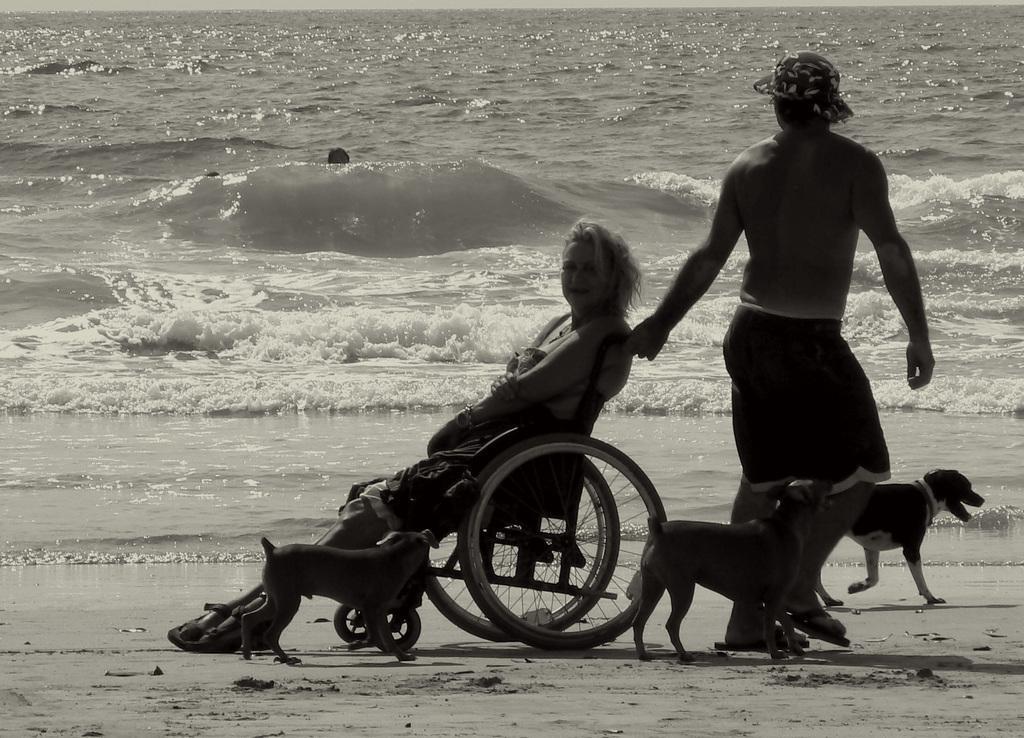Please provide a concise description of this image. This is a black and white picture, in this image we can see a person pulling a wheelchair, we can see a woman on the wheelchair, there are some dogs, in the background we can see the water which looks like a sea. 